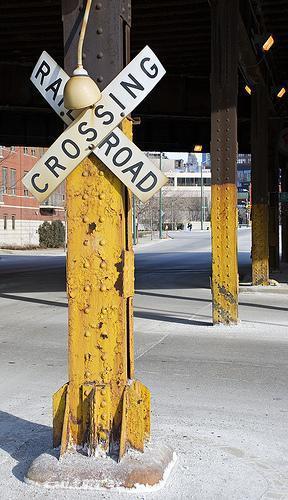How many railroad signs are there?
Give a very brief answer. 1. How many trains pass by this railroad crossing?
Give a very brief answer. 1. 